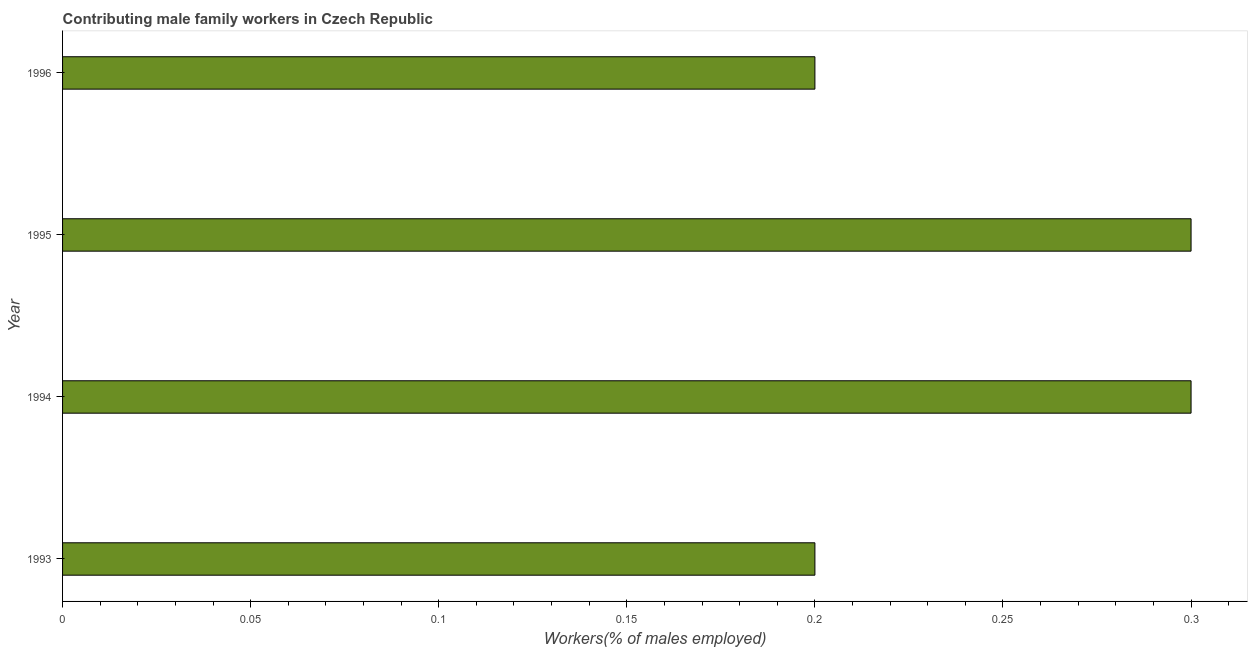Does the graph contain grids?
Keep it short and to the point. No. What is the title of the graph?
Give a very brief answer. Contributing male family workers in Czech Republic. What is the label or title of the X-axis?
Keep it short and to the point. Workers(% of males employed). What is the label or title of the Y-axis?
Your answer should be compact. Year. What is the contributing male family workers in 1995?
Give a very brief answer. 0.3. Across all years, what is the maximum contributing male family workers?
Your response must be concise. 0.3. Across all years, what is the minimum contributing male family workers?
Ensure brevity in your answer.  0.2. In which year was the contributing male family workers maximum?
Offer a very short reply. 1994. What is the sum of the contributing male family workers?
Ensure brevity in your answer.  1. What is the difference between the contributing male family workers in 1994 and 1995?
Keep it short and to the point. 0. What is the average contributing male family workers per year?
Offer a very short reply. 0.25. What is the median contributing male family workers?
Your response must be concise. 0.25. What is the ratio of the contributing male family workers in 1993 to that in 1995?
Your response must be concise. 0.67. What is the difference between the highest and the second highest contributing male family workers?
Make the answer very short. 0. What is the difference between the highest and the lowest contributing male family workers?
Provide a short and direct response. 0.1. In how many years, is the contributing male family workers greater than the average contributing male family workers taken over all years?
Keep it short and to the point. 2. How many bars are there?
Offer a very short reply. 4. What is the Workers(% of males employed) in 1993?
Ensure brevity in your answer.  0.2. What is the Workers(% of males employed) in 1994?
Provide a short and direct response. 0.3. What is the Workers(% of males employed) of 1995?
Your response must be concise. 0.3. What is the Workers(% of males employed) of 1996?
Offer a very short reply. 0.2. What is the difference between the Workers(% of males employed) in 1993 and 1996?
Make the answer very short. 0. What is the difference between the Workers(% of males employed) in 1994 and 1995?
Provide a short and direct response. 0. What is the difference between the Workers(% of males employed) in 1995 and 1996?
Offer a very short reply. 0.1. What is the ratio of the Workers(% of males employed) in 1993 to that in 1994?
Offer a very short reply. 0.67. What is the ratio of the Workers(% of males employed) in 1993 to that in 1995?
Your answer should be compact. 0.67. What is the ratio of the Workers(% of males employed) in 1994 to that in 1995?
Your answer should be very brief. 1. 